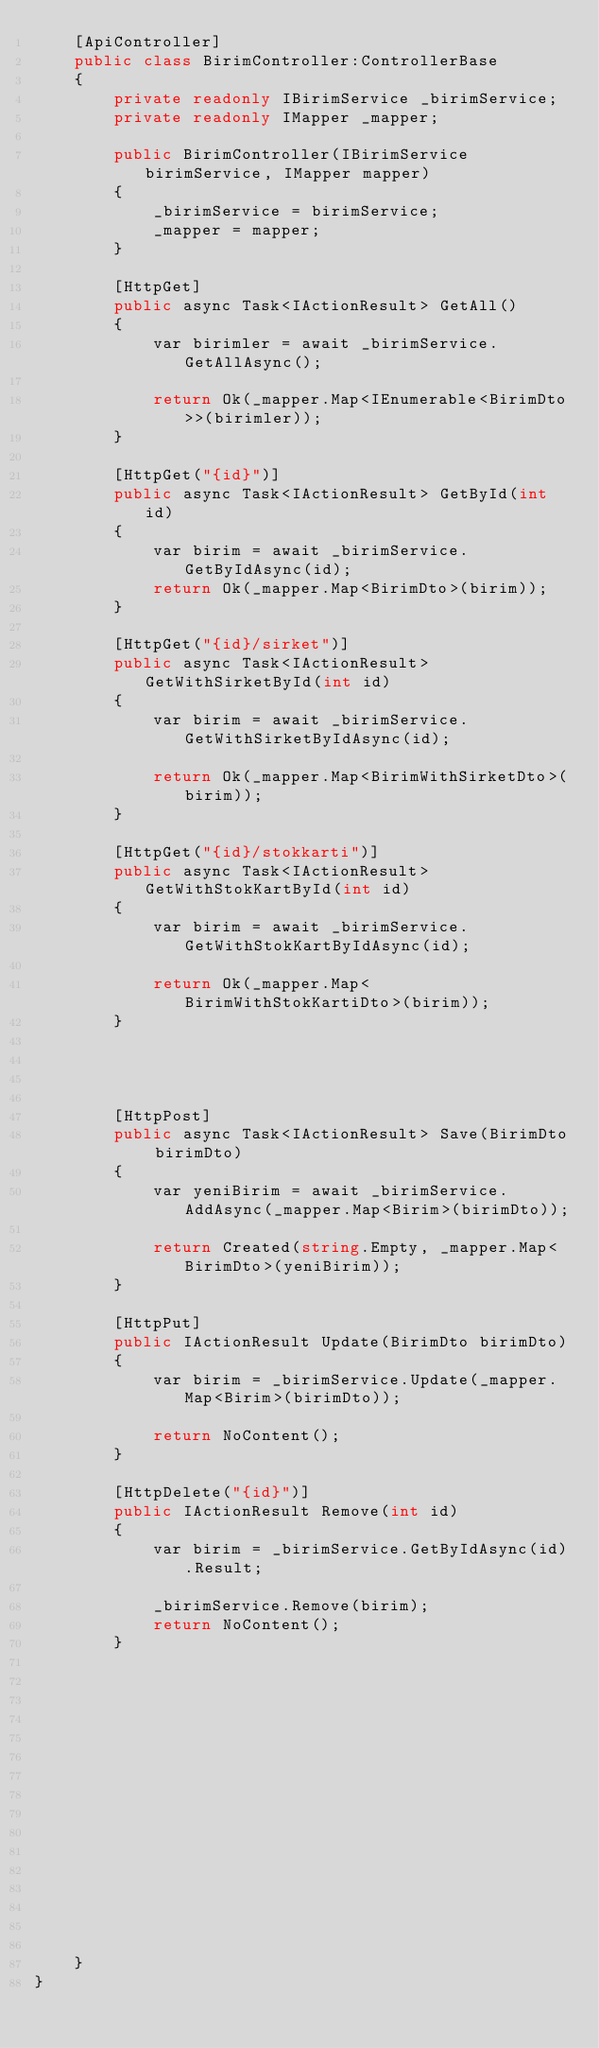<code> <loc_0><loc_0><loc_500><loc_500><_C#_>    [ApiController]
    public class BirimController:ControllerBase
    {
        private readonly IBirimService _birimService;
        private readonly IMapper _mapper;

        public BirimController(IBirimService birimService, IMapper mapper)
        {
            _birimService = birimService;
            _mapper = mapper;
        }

        [HttpGet]
        public async Task<IActionResult> GetAll()
        {
            var birimler = await _birimService.GetAllAsync();

            return Ok(_mapper.Map<IEnumerable<BirimDto>>(birimler));
        }

        [HttpGet("{id}")]
        public async Task<IActionResult> GetById(int id)
        {
            var birim = await _birimService.GetByIdAsync(id);
            return Ok(_mapper.Map<BirimDto>(birim));
        }

        [HttpGet("{id}/sirket")]
        public async Task<IActionResult> GetWithSirketById(int id)
        {
            var birim = await _birimService.GetWithSirketByIdAsync(id);

            return Ok(_mapper.Map<BirimWithSirketDto>(birim));
        }

        [HttpGet("{id}/stokkarti")]
        public async Task<IActionResult> GetWithStokKartById(int id)
        {
            var birim = await _birimService.GetWithStokKartByIdAsync(id);

            return Ok(_mapper.Map<BirimWithStokKartiDto>(birim));
        }

        

         
        [HttpPost]
        public async Task<IActionResult> Save(BirimDto birimDto)
        {
            var yeniBirim = await _birimService.AddAsync(_mapper.Map<Birim>(birimDto));

            return Created(string.Empty, _mapper.Map<BirimDto>(yeniBirim));
        }

        [HttpPut]
        public IActionResult Update(BirimDto birimDto)
        {
            var birim = _birimService.Update(_mapper.Map<Birim>(birimDto));

            return NoContent();
        }

        [HttpDelete("{id}")]
        public IActionResult Remove(int id)
        {
            var birim = _birimService.GetByIdAsync(id).Result;

            _birimService.Remove(birim);
            return NoContent();
        }















        
    }
}</code> 